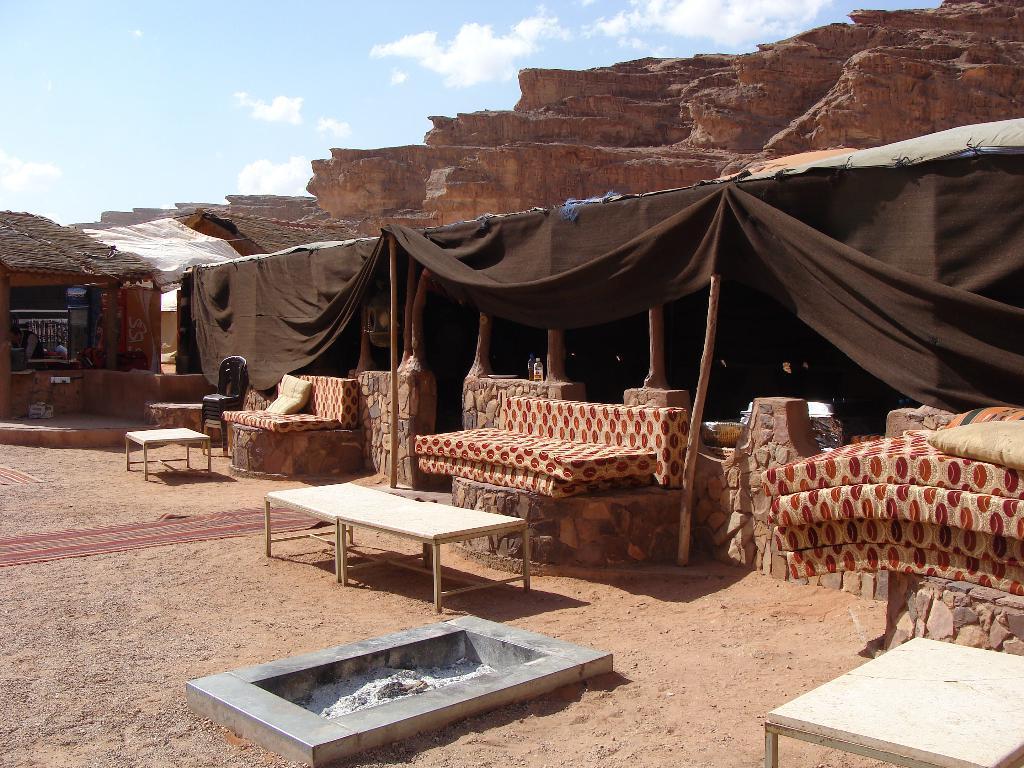Describe this image in one or two sentences. At the bottom of the picture, we see the sand and we see an iron box in which wood ash is placed. Beside that, there are tables. Behind that, we see walls, which are made up of stones. We see beds and pillows placed on the walls. Behind that, we see tents in brown color. On the left side, we see a hut. There are rocks in the background. At the top, we see the sky and the clouds. 